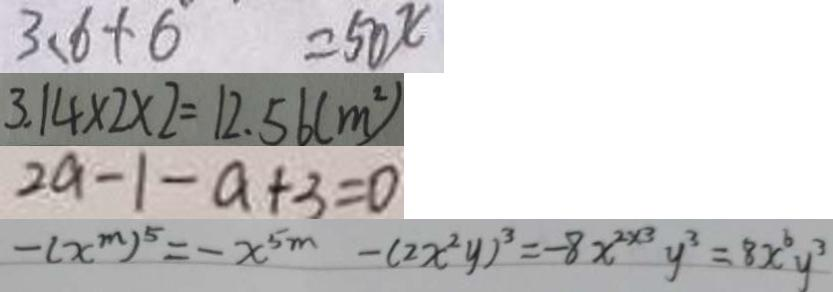Convert formula to latex. <formula><loc_0><loc_0><loc_500><loc_500>3 . 6 + 6 = 5 0 x 
 3 . 1 4 \times 2 \times 2 = 1 2 . 5 6 ( m ^ { 2 } ) 
 2 a - 1 - a + 3 = 0 
 - ( x ^ { m } ) ^ { 5 } = - x ^ { 5 m } - ( 2 x ^ { 2 } y ) ^ { 3 } = - 8 x ^ { 2 \times 3 } y ^ { 3 } = 8 x ^ { 6 } y 3</formula> 